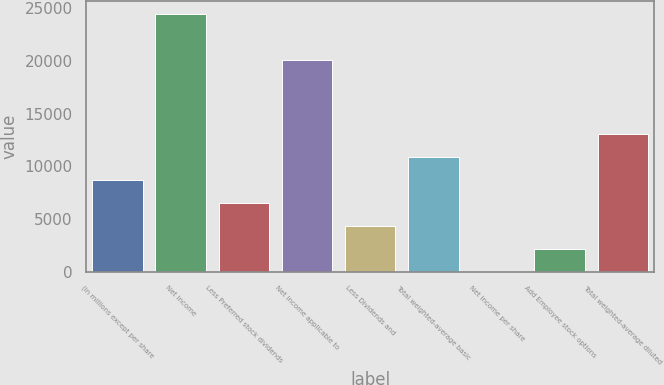Convert chart to OTSL. <chart><loc_0><loc_0><loc_500><loc_500><bar_chart><fcel>(in millions except per share<fcel>Net income<fcel>Less Preferred stock dividends<fcel>Net income applicable to<fcel>Less Dividends and<fcel>Total weighted-average basic<fcel>Net income per share<fcel>Add Employee stock options<fcel>Total weighted-average diluted<nl><fcel>8708.02<fcel>24444.3<fcel>6532.35<fcel>20093<fcel>4356.68<fcel>10883.7<fcel>5.34<fcel>2181.01<fcel>13059.4<nl></chart> 